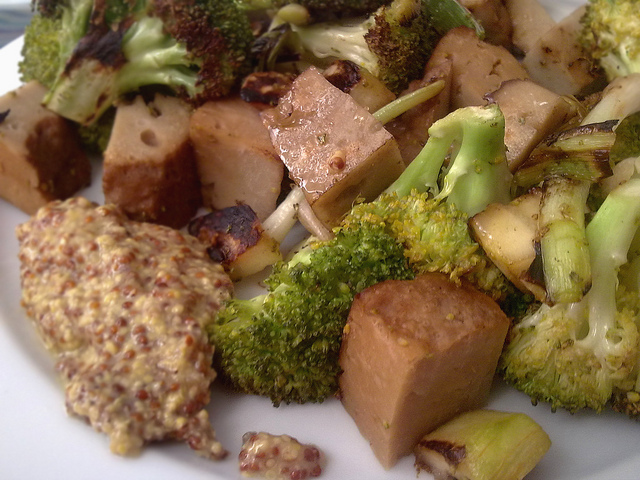What type of cuisine does this dish represent? This dish appears to be inspired by Asian cuisine, possibly incorporating elements commonly found in vegetarian or vegan recipes, such as tofu and a variety of vegetables. 